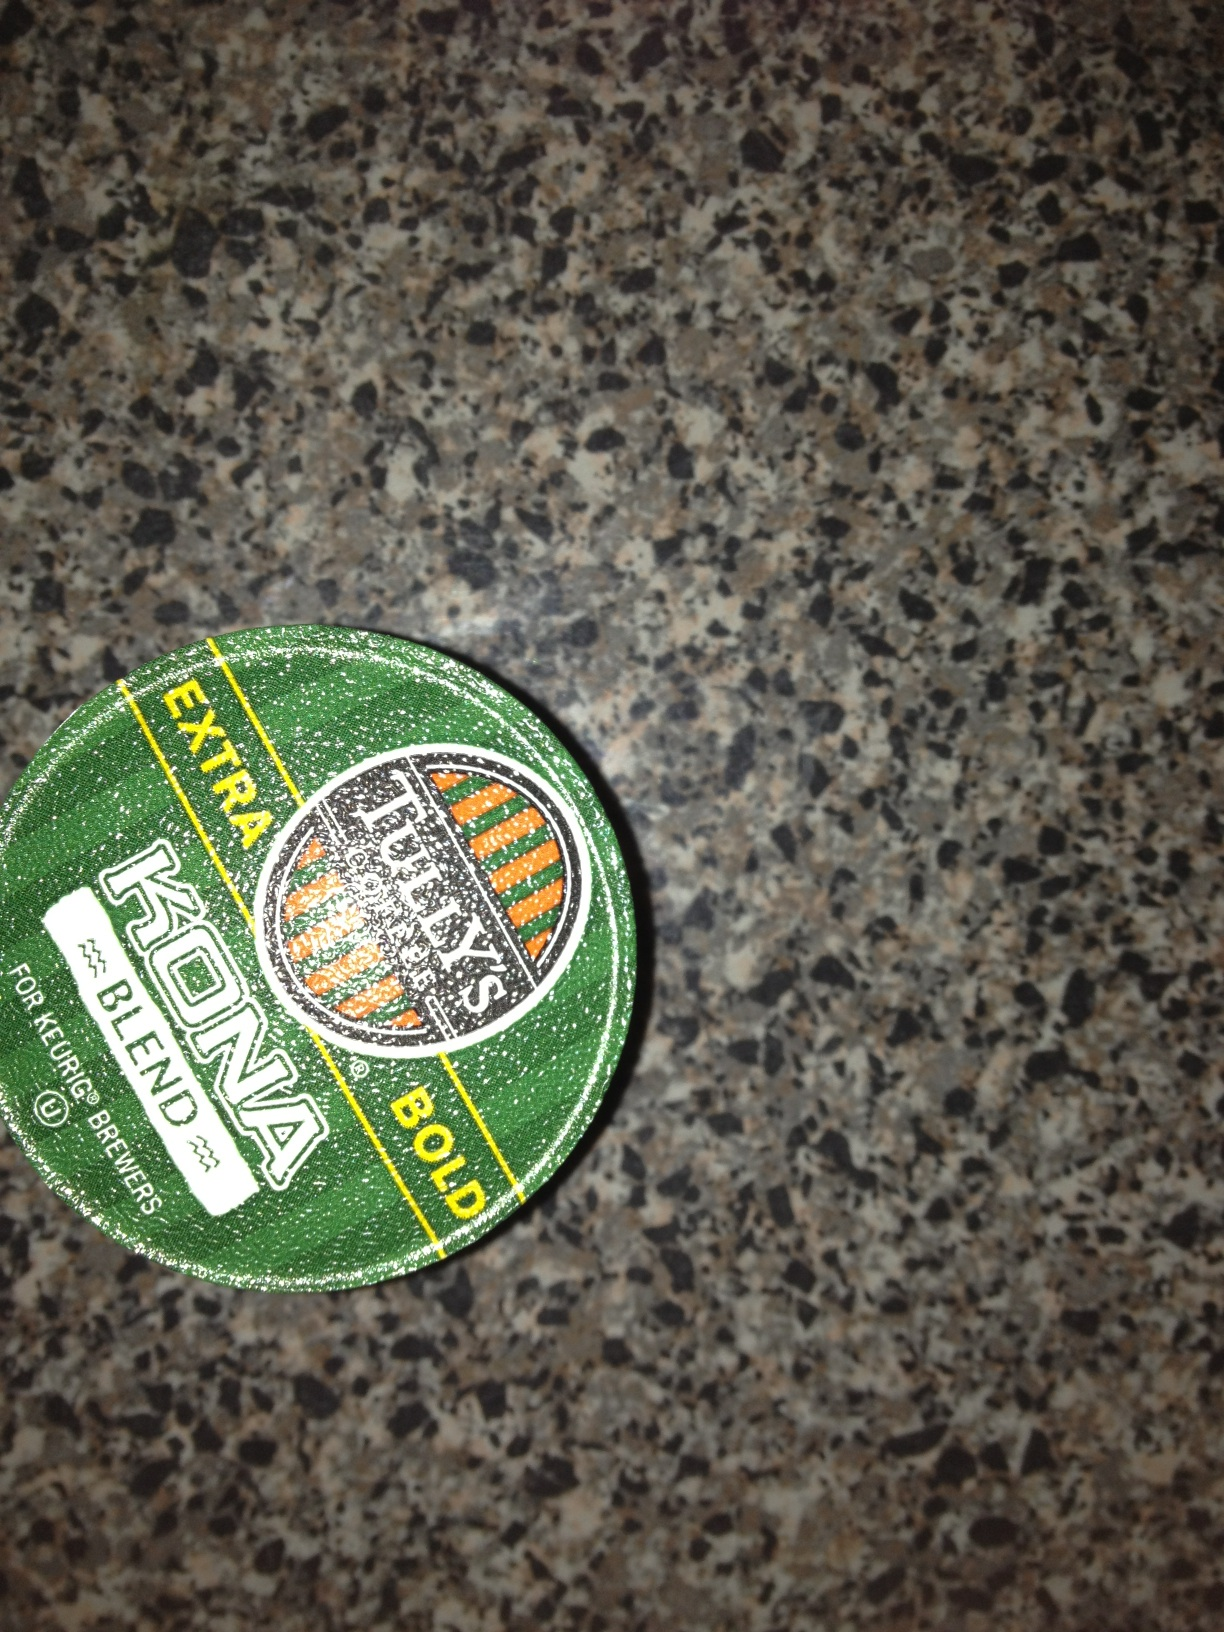What kind of coffee is this? This is a Tully's Extra Bold Kona Blend coffee pod, specifically designed for Keurig brewers. The 'Extra Bold' indicates a deeper, richer coffee flavor with a stronger body, perfect for those who prefer a more robust cup of coffee. 